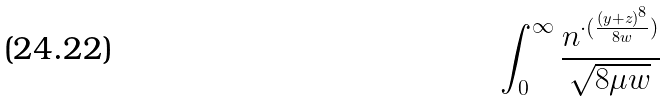<formula> <loc_0><loc_0><loc_500><loc_500>\int _ { 0 } ^ { \infty } \frac { n ^ { \cdot ( \frac { ( y + z ) ^ { 8 } } { 8 w } ) } } { \sqrt { 8 \mu w } }</formula> 